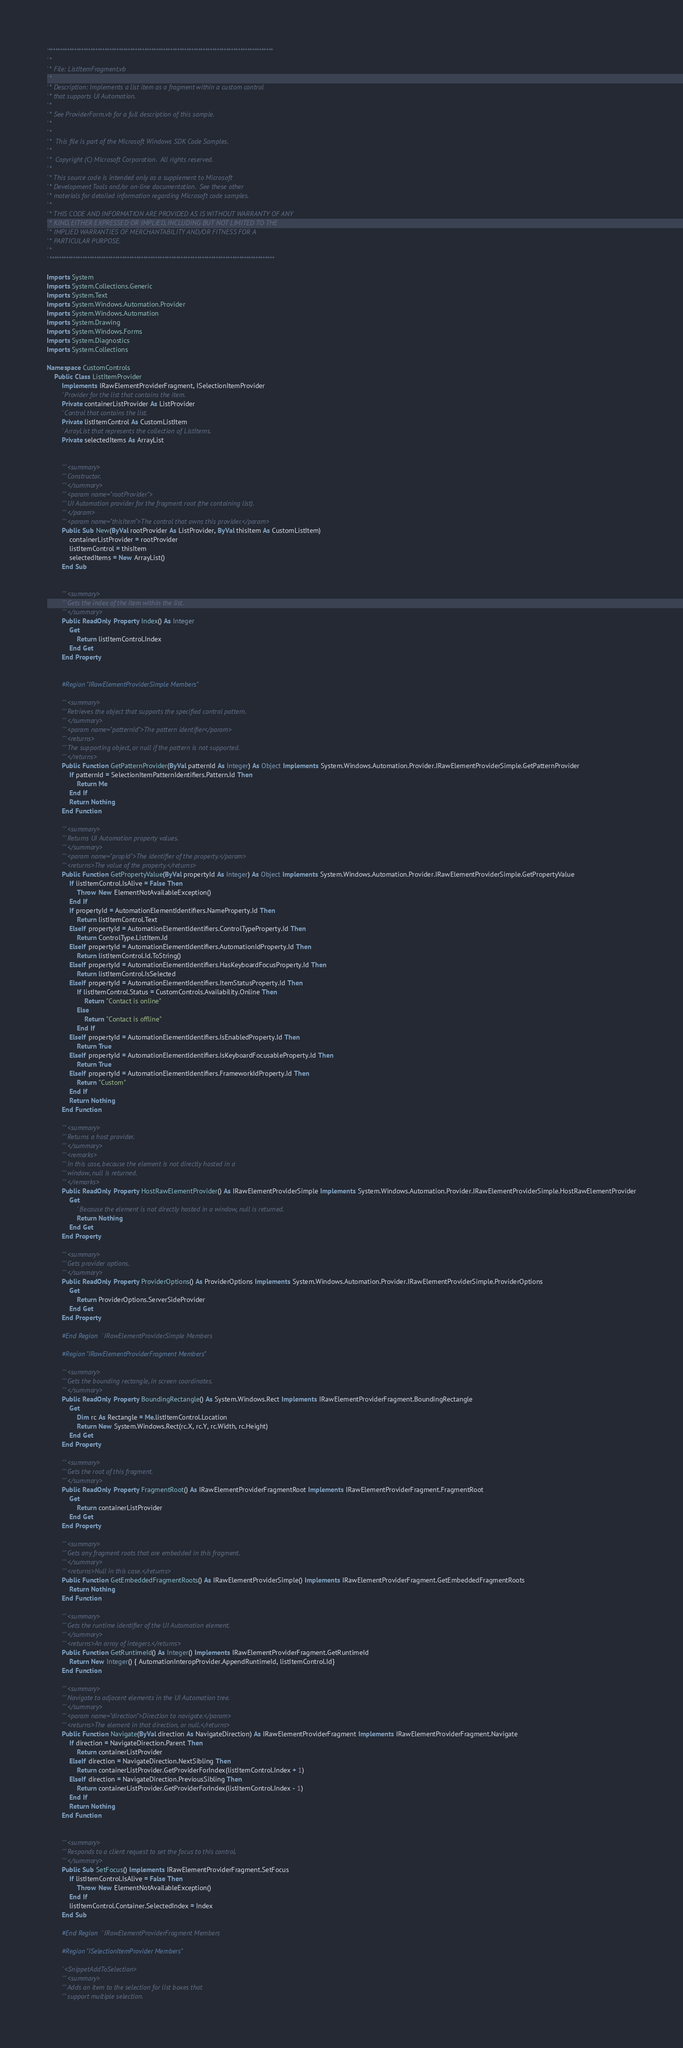<code> <loc_0><loc_0><loc_500><loc_500><_VisualBasic_>'************************************************************************************************
' *
' * File: ListItemFragment.vb
' *
' * Description: Implements a list item as a fragment within a custom control 
' * that supports UI Automation.
' * 
' * See ProviderForm.vb for a full description of this sample.
' *   
' * 
' *  This file is part of the Microsoft Windows SDK Code Samples.
' * 
' *  Copyright (C) Microsoft Corporation.  All rights reserved.
' * 
' * This source code is intended only as a supplement to Microsoft
' * Development Tools and/or on-line documentation.  See these other
' * materials for detailed information regarding Microsoft code samples.
' * 
' * THIS CODE AND INFORMATION ARE PROVIDED AS IS WITHOUT WARRANTY OF ANY
' * KIND, EITHER EXPRESSED OR IMPLIED, INCLUDING BUT NOT LIMITED TO THE
' * IMPLIED WARRANTIES OF MERCHANTABILITY AND/OR FITNESS FOR A
' * PARTICULAR PURPOSE.
' * 
' ************************************************************************************************

Imports System
Imports System.Collections.Generic
Imports System.Text
Imports System.Windows.Automation.Provider
Imports System.Windows.Automation
Imports System.Drawing
Imports System.Windows.Forms
Imports System.Diagnostics
Imports System.Collections

Namespace CustomControls
	Public Class ListItemProvider
		Implements IRawElementProviderFragment, ISelectionItemProvider
		' Provider for the list that contains the item.
		Private containerListProvider As ListProvider
		' Control that contains the list.
		Private listItemControl As CustomListItem
		' ArrayList that represents the collection of ListItems.
		Private selectedItems As ArrayList


		''' <summary>
		''' Constructor.
		''' </summary>
		''' <param name="rootProvider">
		''' UI Automation provider for the fragment root (the containing list).
		''' </param>
		''' <param name="thisItem">The control that owns this provider.</param>
		Public Sub New(ByVal rootProvider As ListProvider, ByVal thisItem As CustomListItem)
			containerListProvider = rootProvider
			listItemControl = thisItem
			selectedItems = New ArrayList()
		End Sub


		''' <summary>
		''' Gets the index of the item within the list.
		''' </summary>
		Public ReadOnly Property Index() As Integer
			Get
				Return listItemControl.Index
			End Get
		End Property


		#Region "IRawElementProviderSimple Members"

		''' <summary>
		''' Retrieves the object that supports the specified control pattern.
		''' </summary>
		''' <param name="patternId">The pattern identifier</param>
		''' <returns>
		''' The supporting object, or null if the pattern is not supported.
		''' </returns>
		Public Function GetPatternProvider(ByVal patternId As Integer) As Object Implements System.Windows.Automation.Provider.IRawElementProviderSimple.GetPatternProvider
			If patternId = SelectionItemPatternIdentifiers.Pattern.Id Then
				Return Me
			End If
			Return Nothing
		End Function

		''' <summary>
		''' Returns UI Automation property values.
		''' </summary>
		''' <param name="propId">The identifier of the property.</param>
		''' <returns>The value of the property.</returns>
		Public Function GetPropertyValue(ByVal propertyId As Integer) As Object Implements System.Windows.Automation.Provider.IRawElementProviderSimple.GetPropertyValue
			If listItemControl.IsAlive = False Then
				Throw New ElementNotAvailableException()
			End If
			If propertyId = AutomationElementIdentifiers.NameProperty.Id Then
				Return listItemControl.Text
			ElseIf propertyId = AutomationElementIdentifiers.ControlTypeProperty.Id Then
				Return ControlType.ListItem.Id
			ElseIf propertyId = AutomationElementIdentifiers.AutomationIdProperty.Id Then
				Return listItemControl.Id.ToString()
			ElseIf propertyId = AutomationElementIdentifiers.HasKeyboardFocusProperty.Id Then
				Return listItemControl.IsSelected
			ElseIf propertyId = AutomationElementIdentifiers.ItemStatusProperty.Id Then
				If listItemControl.Status = CustomControls.Availability.Online Then
					Return "Contact is online"
				Else
					Return "Contact is offline"
				End If
			ElseIf propertyId = AutomationElementIdentifiers.IsEnabledProperty.Id Then
				Return True
			ElseIf propertyId = AutomationElementIdentifiers.IsKeyboardFocusableProperty.Id Then
				Return True
			ElseIf propertyId = AutomationElementIdentifiers.FrameworkIdProperty.Id Then
				Return "Custom"
			End If
			Return Nothing
		End Function

		''' <summary>
		''' Returns a host provider. 
		''' </summary>
		''' <remarks>
		''' In this case, because the element is not directly hosted in a
		''' window, null is returned.
		''' </remarks>
		Public ReadOnly Property HostRawElementProvider() As IRawElementProviderSimple Implements System.Windows.Automation.Provider.IRawElementProviderSimple.HostRawElementProvider
			Get
				' Because the element is not directly hosted in a window, null is returned.
				Return Nothing
			End Get
		End Property

		''' <summary>
		''' Gets provider options.
		''' </summary>
		Public ReadOnly Property ProviderOptions() As ProviderOptions Implements System.Windows.Automation.Provider.IRawElementProviderSimple.ProviderOptions
			Get
				Return ProviderOptions.ServerSideProvider
			End Get
		End Property

		#End Region ' IRawElementProviderSimple Members

		#Region "IRawElementProviderFragment Members"

		''' <summary>
		''' Gets the bounding rectangle, in screen coordinates.
		''' </summary>
		Public ReadOnly Property BoundingRectangle() As System.Windows.Rect Implements IRawElementProviderFragment.BoundingRectangle
			Get
				Dim rc As Rectangle = Me.listItemControl.Location
				Return New System.Windows.Rect(rc.X, rc.Y, rc.Width, rc.Height)
			End Get
		End Property

		''' <summary>
		''' Gets the root of this fragment.
		''' </summary>
		Public ReadOnly Property FragmentRoot() As IRawElementProviderFragmentRoot Implements IRawElementProviderFragment.FragmentRoot
			Get
				Return containerListProvider
			End Get
		End Property

		''' <summary>
		''' Gets any fragment roots that are embedded in this fragment.
		''' </summary>
		''' <returns>Null in this case.</returns>
		Public Function GetEmbeddedFragmentRoots() As IRawElementProviderSimple() Implements IRawElementProviderFragment.GetEmbeddedFragmentRoots
			Return Nothing
		End Function

		''' <summary>
		''' Gets the runtime identifier of the UI Automation element.
		''' </summary>
		''' <returns>An array of integers.</returns>
		Public Function GetRuntimeId() As Integer() Implements IRawElementProviderFragment.GetRuntimeId
			Return New Integer() { AutomationInteropProvider.AppendRuntimeId, listItemControl.Id}
		End Function

		''' <summary>
		''' Navigate to adjacent elements in the UI Automation tree.
		''' </summary>
		''' <param name="direction">Direction to navigate.</param>
		''' <returns>The element in that direction, or null.</returns>
		Public Function Navigate(ByVal direction As NavigateDirection) As IRawElementProviderFragment Implements IRawElementProviderFragment.Navigate
			If direction = NavigateDirection.Parent Then
				Return containerListProvider
			ElseIf direction = NavigateDirection.NextSibling Then
				Return containerListProvider.GetProviderForIndex(listItemControl.Index + 1)
			ElseIf direction = NavigateDirection.PreviousSibling Then
				Return containerListProvider.GetProviderForIndex(listItemControl.Index - 1)
			End If
			Return Nothing
		End Function


		''' <summary>
		''' Responds to a client request to set the focus to this control. 
		''' </summary>
		Public Sub SetFocus() Implements IRawElementProviderFragment.SetFocus
			If listItemControl.IsAlive = False Then
				Throw New ElementNotAvailableException()
			End If
			listItemControl.Container.SelectedIndex = Index
		End Sub

		#End Region ' IRawElementProviderFragment Members

		#Region "ISelectionItemProvider Members"

		' <SnippetAddToSelection>
		''' <summary>
		''' Adds an item to the selection for list boxes that 
		''' support multiple selection.</code> 